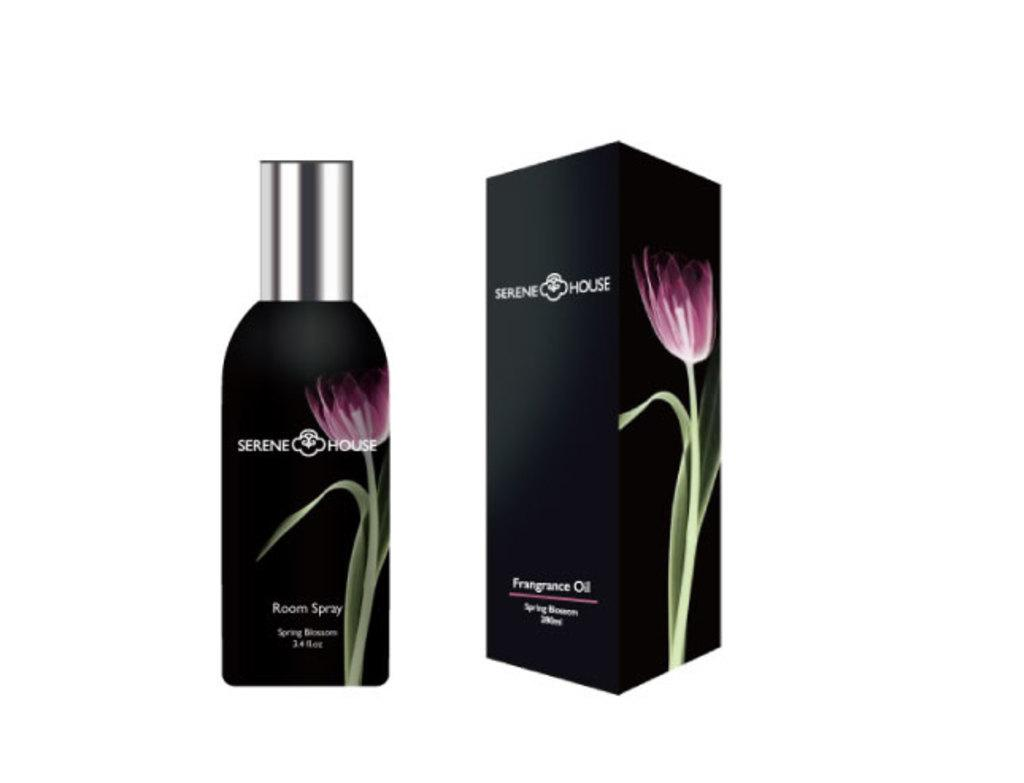<image>
Render a clear and concise summary of the photo. Serene House Spring Blossom Room Spray bottle stands next to a packaging box with the same colors. 